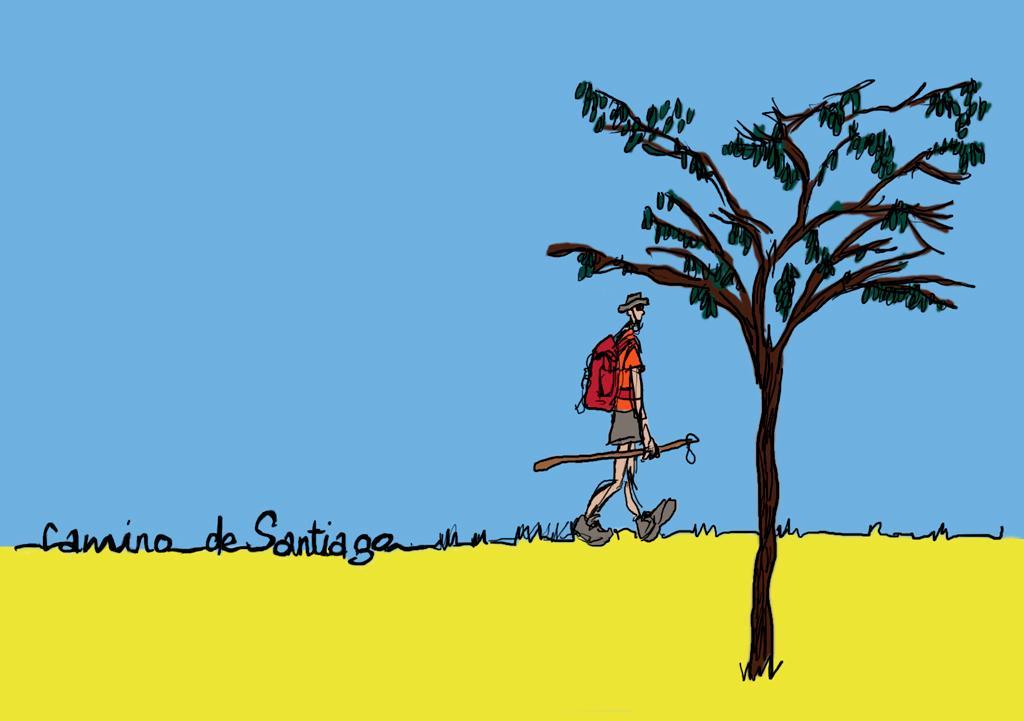Describe this image in one or two sentences. This is a cartoon image where we can see a person is walking on the grass by holding a stick in the hand and carrying a bag on the shoulders. On the right side we can see a tree. There is a text written on the image. In the background we can see the sky. 